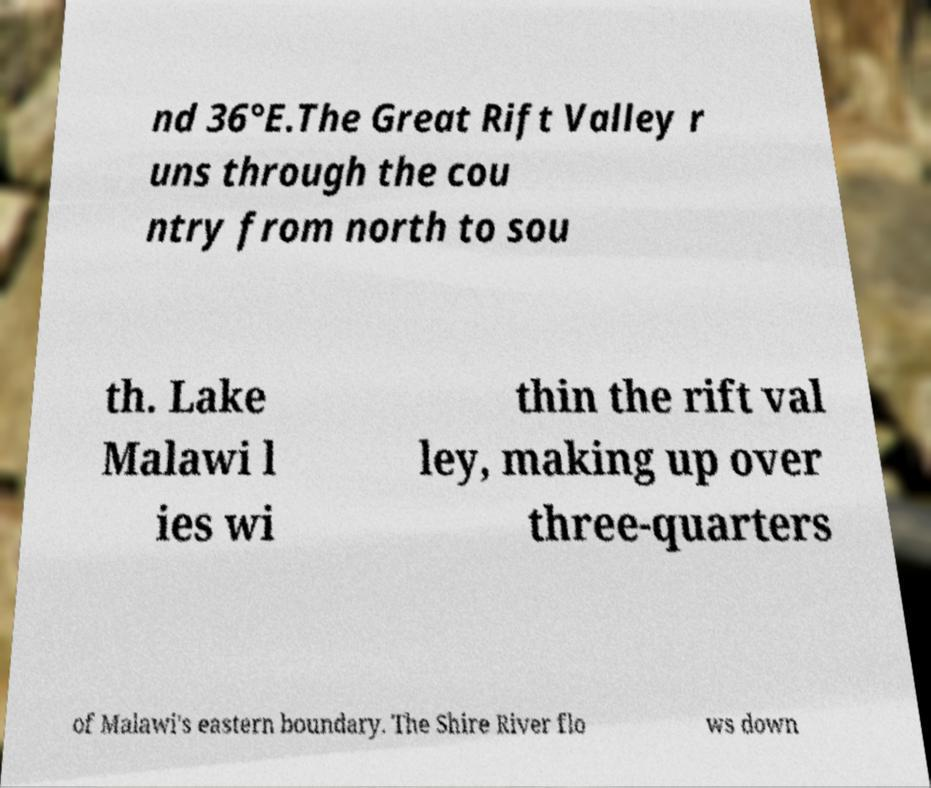Could you extract and type out the text from this image? nd 36°E.The Great Rift Valley r uns through the cou ntry from north to sou th. Lake Malawi l ies wi thin the rift val ley, making up over three-quarters of Malawi's eastern boundary. The Shire River flo ws down 